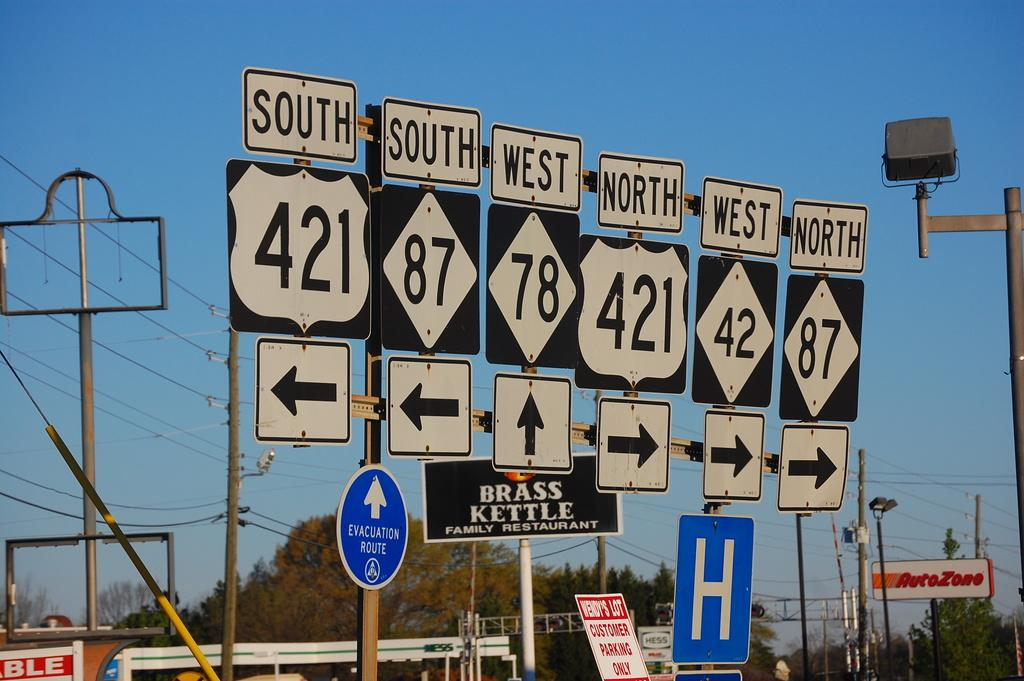What type of signs are present in the image? There are directional boards in the image. What else can be seen in the image besides the directional boards? There are poles and lights visible in the image. What can be seen in the background of the image? There are trees and the sky visible in the background of the image. How many cherries are hanging from the poles in the image? There are no cherries present in the image; it features directional boards, poles, lights, trees, and the sky. What sound does the bell make in the image? There is no bell present in the image. 